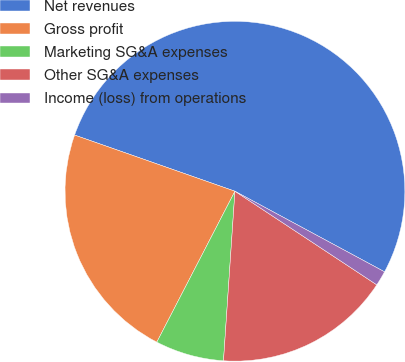Convert chart. <chart><loc_0><loc_0><loc_500><loc_500><pie_chart><fcel>Net revenues<fcel>Gross profit<fcel>Marketing SG&A expenses<fcel>Other SG&A expenses<fcel>Income (loss) from operations<nl><fcel>52.5%<fcel>22.76%<fcel>6.53%<fcel>16.79%<fcel>1.42%<nl></chart> 